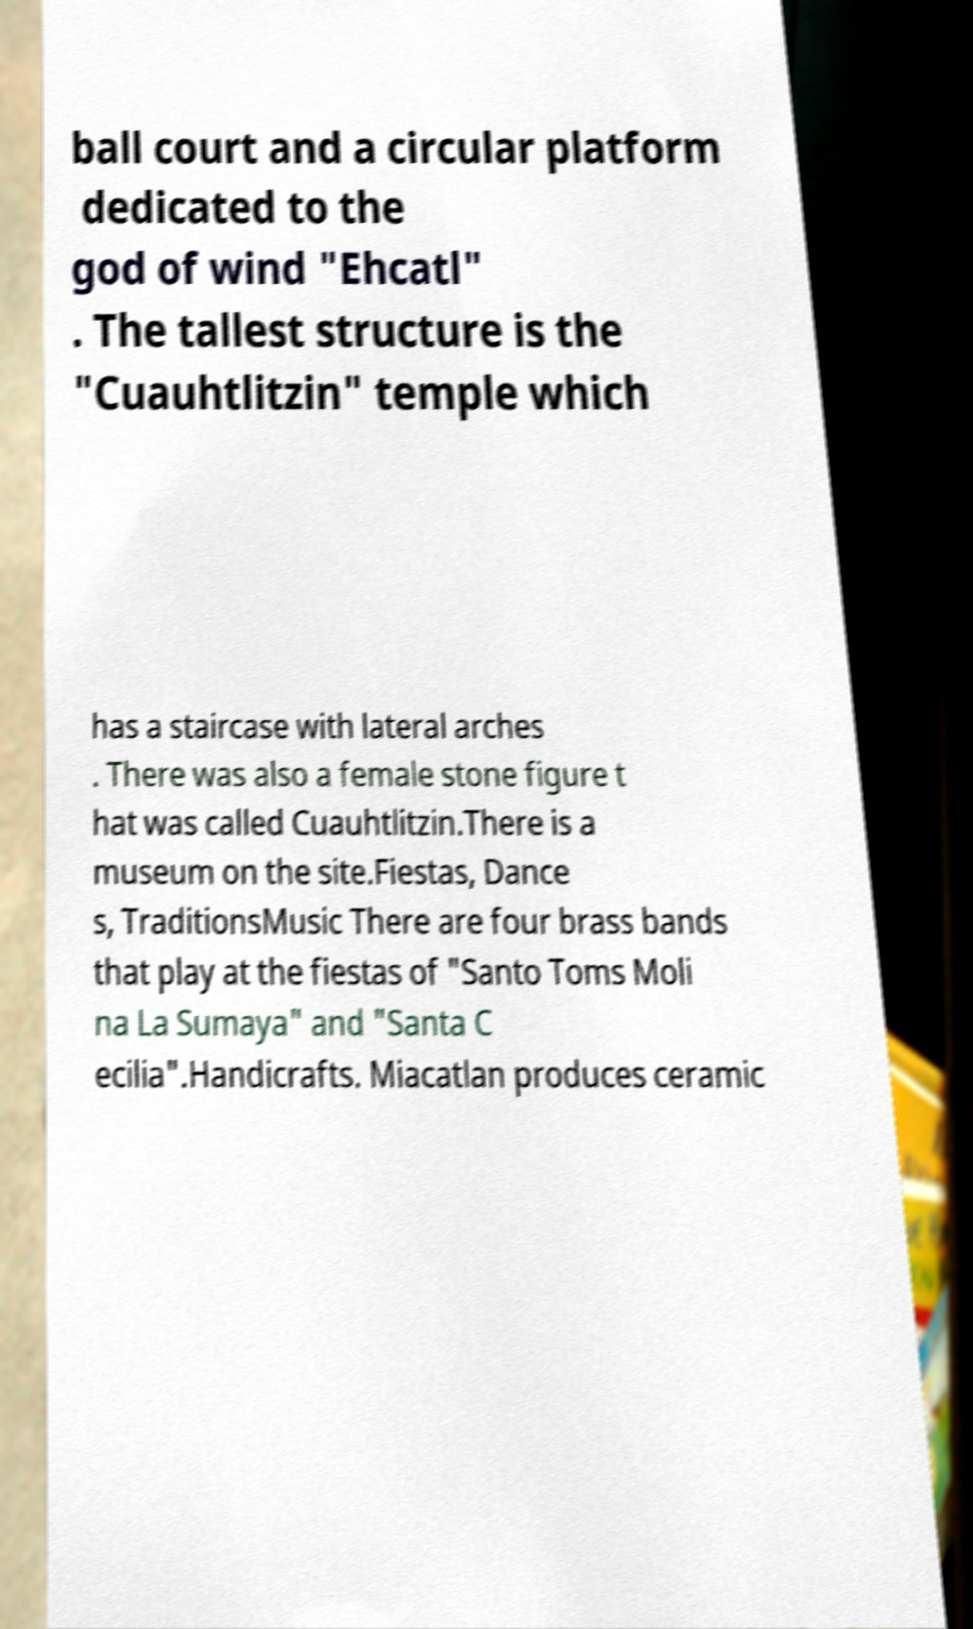What messages or text are displayed in this image? I need them in a readable, typed format. ball court and a circular platform dedicated to the god of wind "Ehcatl" . The tallest structure is the "Cuauhtlitzin" temple which has a staircase with lateral arches . There was also a female stone figure t hat was called Cuauhtlitzin.There is a museum on the site.Fiestas, Dance s, TraditionsMusic There are four brass bands that play at the fiestas of "Santo Toms Moli na La Sumaya" and "Santa C ecilia".Handicrafts. Miacatlan produces ceramic 